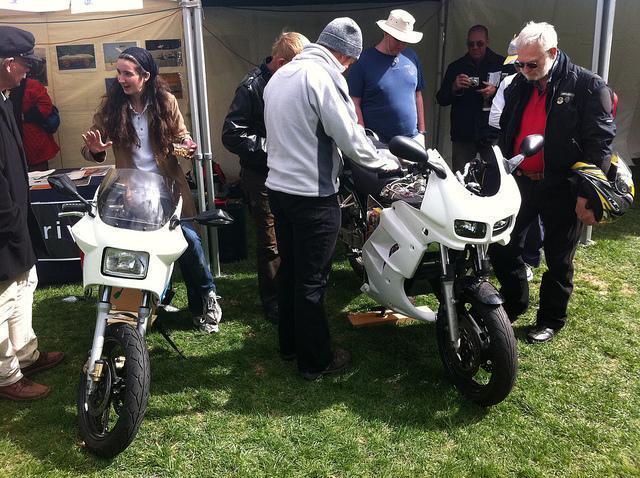What animal is the same color as the bike?
Indicate the correct response by choosing from the four available options to answer the question.
Options: Panther, leopard, swan, giraffe. Swan. 